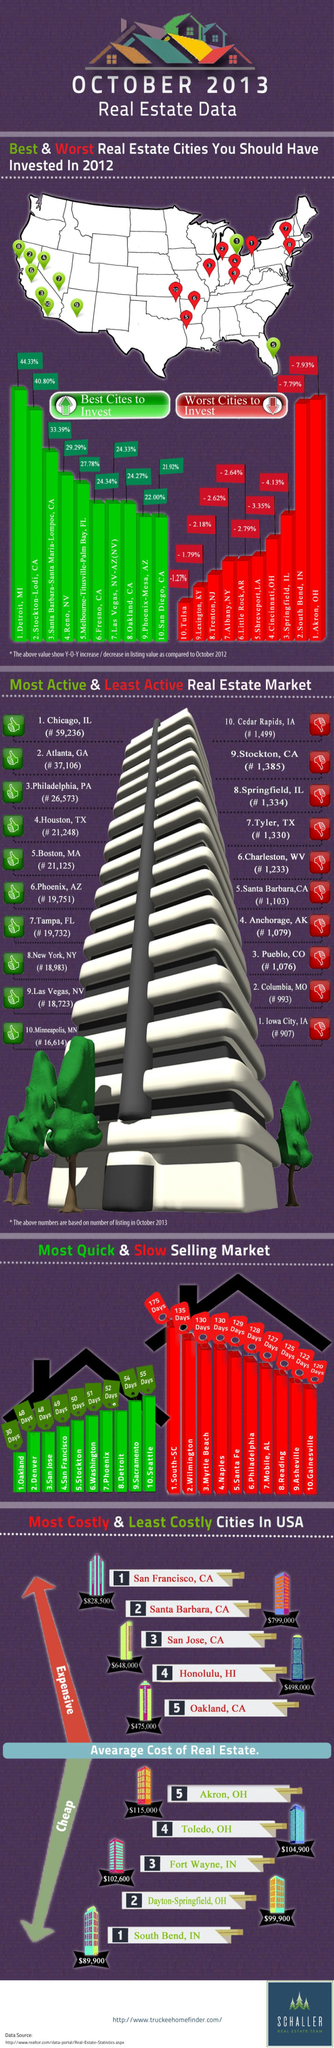Outline some significant characteristics in this image. The third-best city for investment has a percentage of 33.39%. Stockton-Lodi, California is the second most desirable city for investment. 